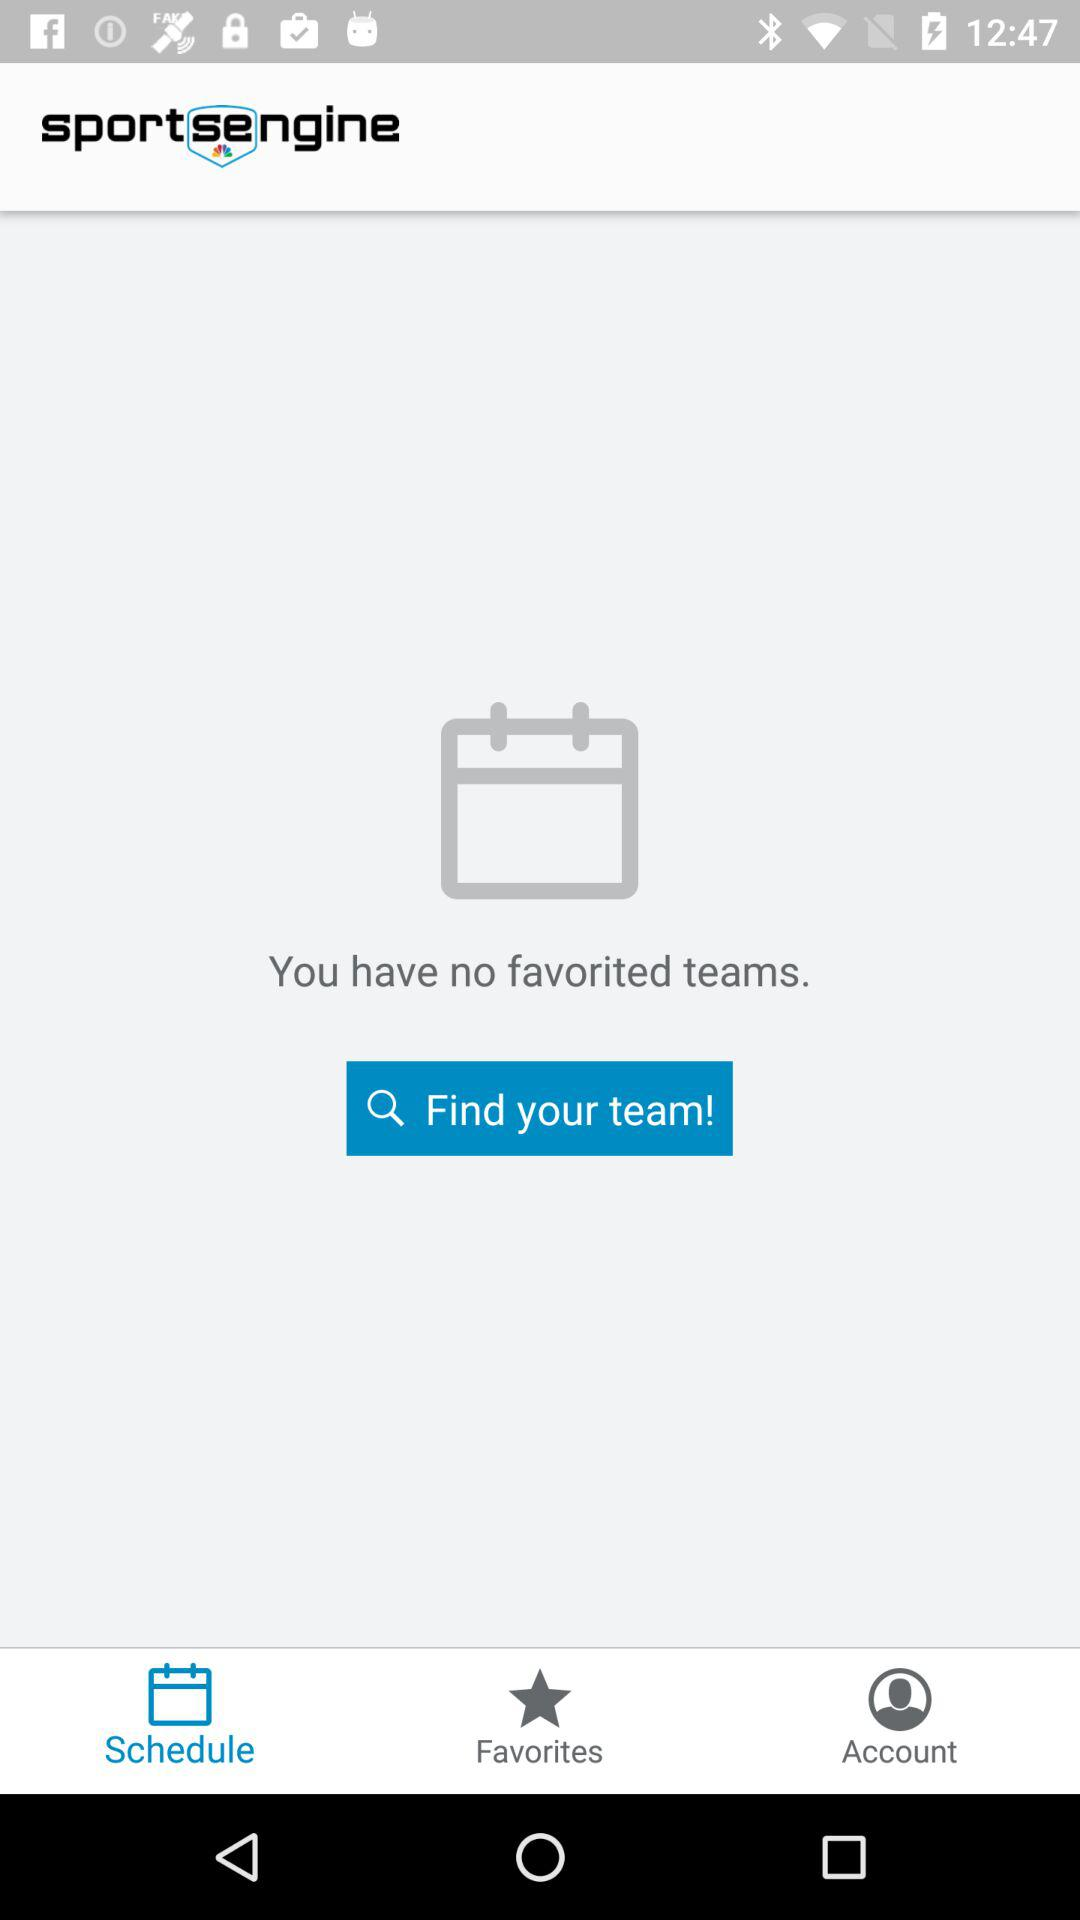What is the selected tab? The selected tab is "Schedule". 